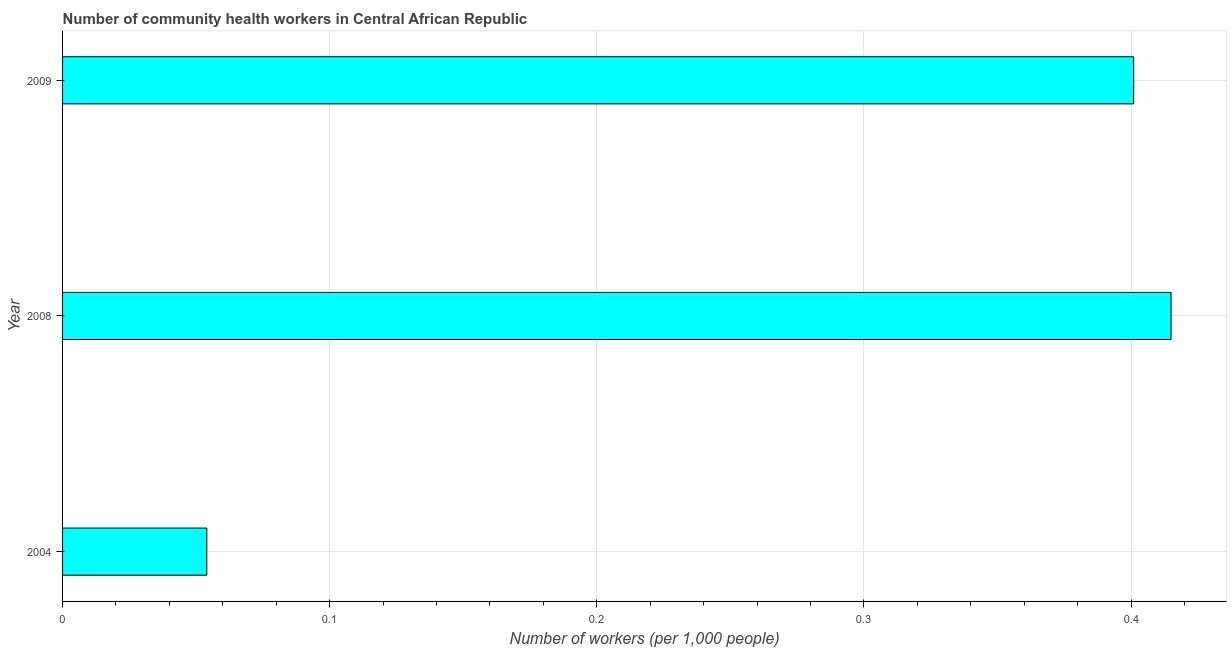Does the graph contain any zero values?
Make the answer very short. No. What is the title of the graph?
Keep it short and to the point. Number of community health workers in Central African Republic. What is the label or title of the X-axis?
Offer a terse response. Number of workers (per 1,0 people). What is the number of community health workers in 2008?
Provide a succinct answer. 0.41. Across all years, what is the maximum number of community health workers?
Provide a short and direct response. 0.41. Across all years, what is the minimum number of community health workers?
Offer a terse response. 0.05. In which year was the number of community health workers maximum?
Ensure brevity in your answer.  2008. What is the sum of the number of community health workers?
Provide a short and direct response. 0.87. What is the difference between the number of community health workers in 2008 and 2009?
Ensure brevity in your answer.  0.01. What is the average number of community health workers per year?
Give a very brief answer. 0.29. What is the median number of community health workers?
Offer a very short reply. 0.4. What is the ratio of the number of community health workers in 2004 to that in 2009?
Keep it short and to the point. 0.14. What is the difference between the highest and the second highest number of community health workers?
Make the answer very short. 0.01. Is the sum of the number of community health workers in 2008 and 2009 greater than the maximum number of community health workers across all years?
Make the answer very short. Yes. What is the difference between the highest and the lowest number of community health workers?
Your response must be concise. 0.36. How many bars are there?
Ensure brevity in your answer.  3. What is the Number of workers (per 1,000 people) in 2004?
Your answer should be compact. 0.05. What is the Number of workers (per 1,000 people) of 2008?
Your answer should be compact. 0.41. What is the Number of workers (per 1,000 people) of 2009?
Your response must be concise. 0.4. What is the difference between the Number of workers (per 1,000 people) in 2004 and 2008?
Your response must be concise. -0.36. What is the difference between the Number of workers (per 1,000 people) in 2004 and 2009?
Give a very brief answer. -0.35. What is the difference between the Number of workers (per 1,000 people) in 2008 and 2009?
Make the answer very short. 0.01. What is the ratio of the Number of workers (per 1,000 people) in 2004 to that in 2008?
Give a very brief answer. 0.13. What is the ratio of the Number of workers (per 1,000 people) in 2004 to that in 2009?
Your answer should be compact. 0.14. What is the ratio of the Number of workers (per 1,000 people) in 2008 to that in 2009?
Provide a succinct answer. 1.03. 